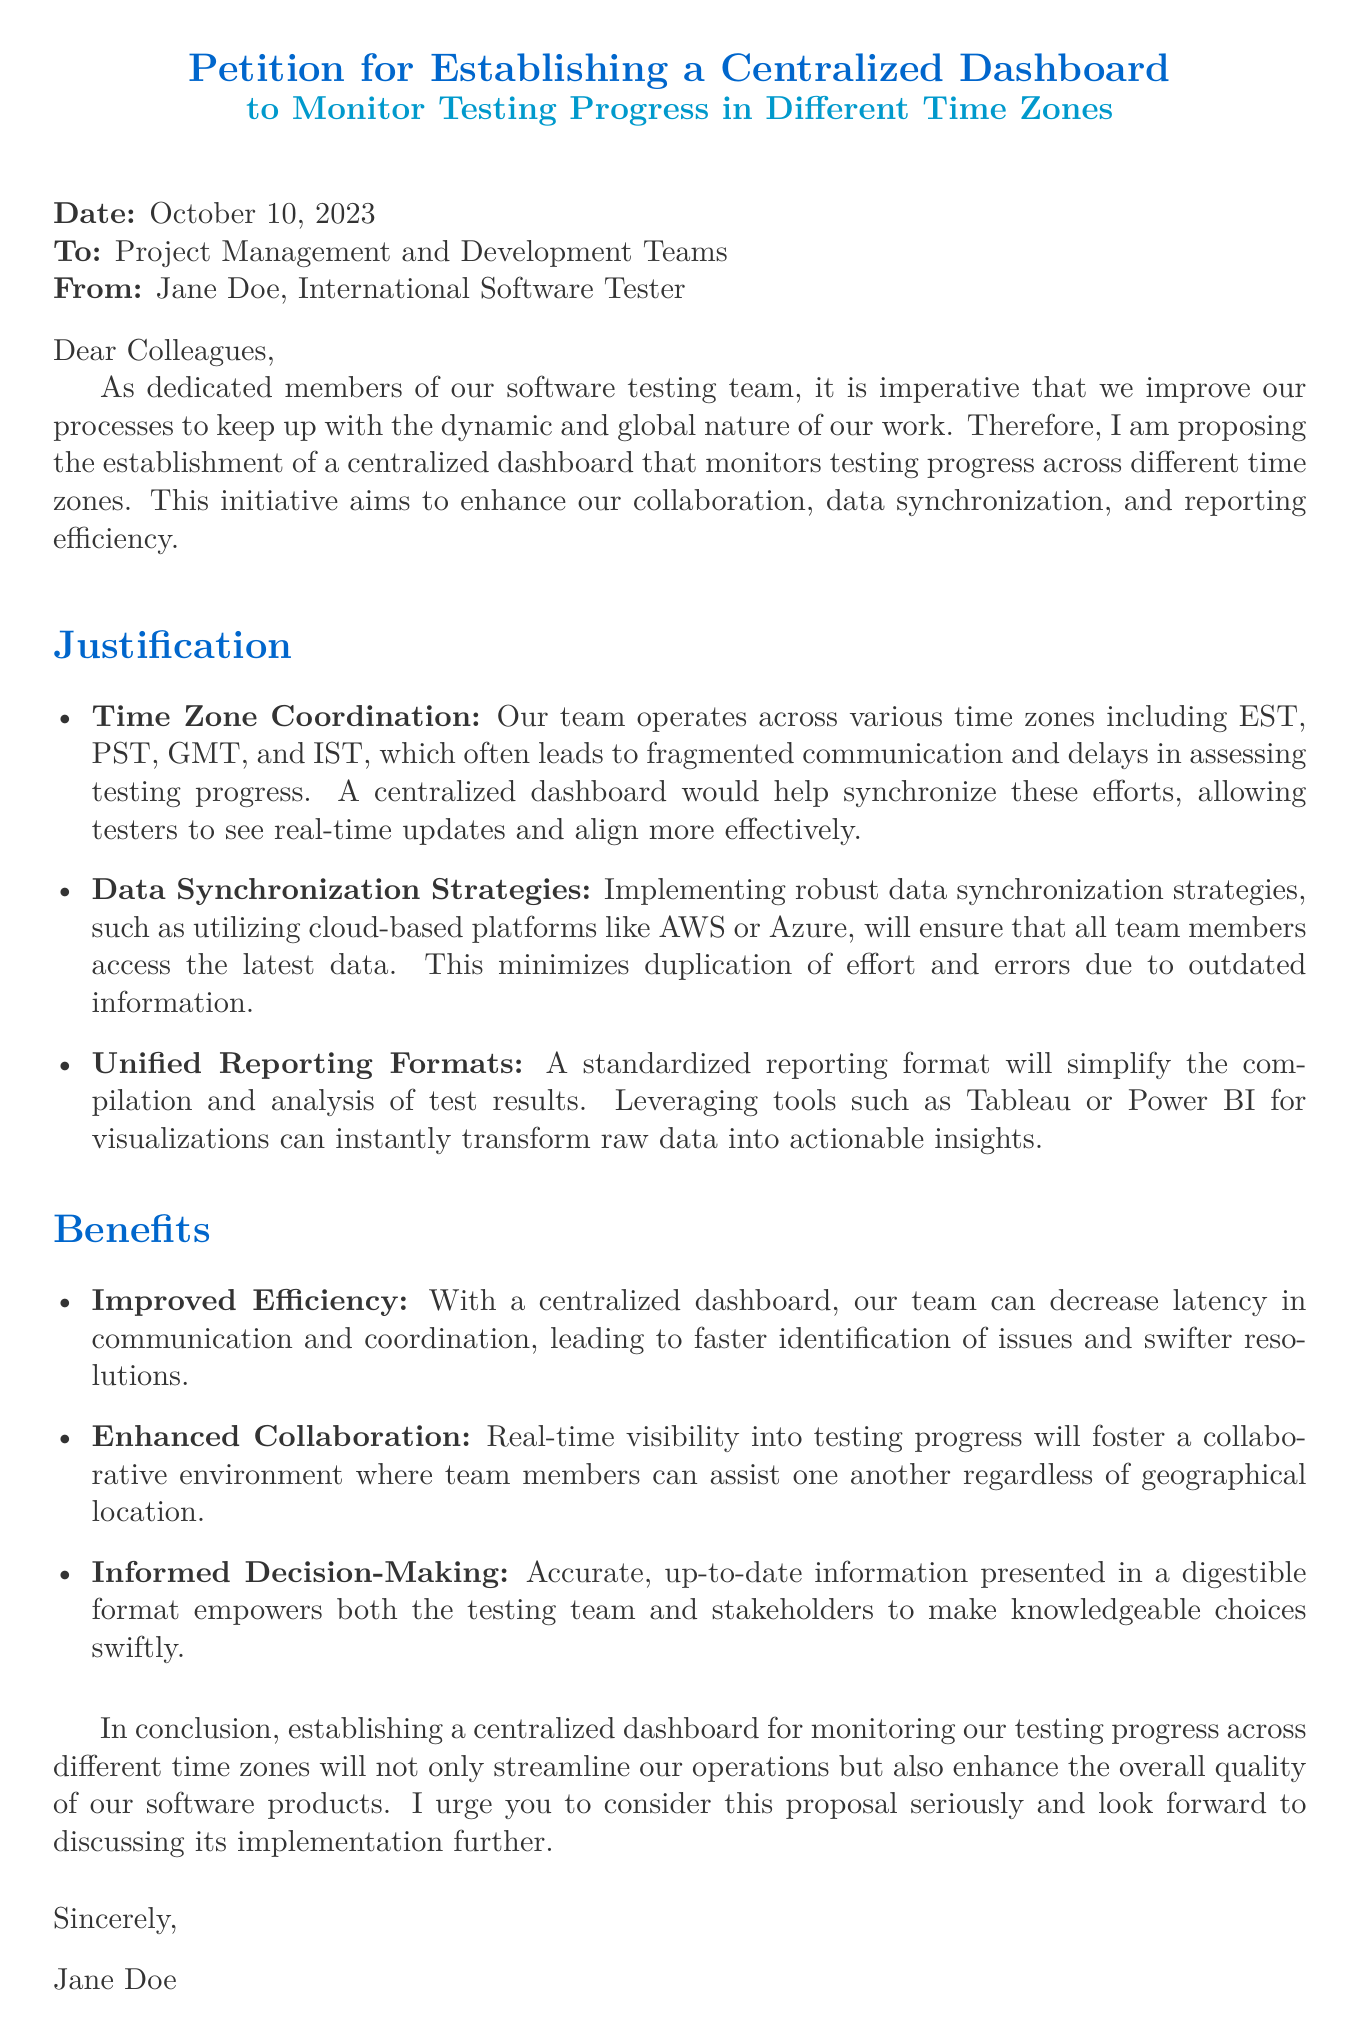What is the date of the petition? The date of the petition is explicitly stated at the beginning of the document.
Answer: October 10, 2023 Who is the author of the petition? The petition identifies the author in the "From" section.
Answer: Jane Doe What is the main purpose of the proposed dashboard? The purpose is summarized in the introductory paragraph of the document.
Answer: Monitoring testing progress Which cloud platforms are suggested for data synchronization? The document mentions specific cloud platforms for this purpose.
Answer: AWS or Azure What are the benefits associated with establishing the centralized dashboard? The benefits are listed in a dedicated section of the document.
Answer: Improved Efficiency How many time zones does the team operate across? The document states the specific time zones the team works in.
Answer: Four What type of reporting formats are proposed for standardization? The document refers to specific tools as suggested reporting formats.
Answer: Tableau or Power BI What does the author urge the recipients to do? The call to action is found in the conclusion of the petition.
Answer: Consider this proposal What is the overall aim of the petition? The overall aim can be inferred from the closing statements.
Answer: Enhance the overall quality of our software products 